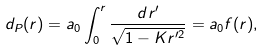<formula> <loc_0><loc_0><loc_500><loc_500>d _ { P } ( r ) = a _ { 0 } \int ^ { r } _ { 0 } \frac { d r ^ { \prime } } { \sqrt { 1 - K r ^ { \prime 2 } } } = a _ { 0 } f ( r ) ,</formula> 